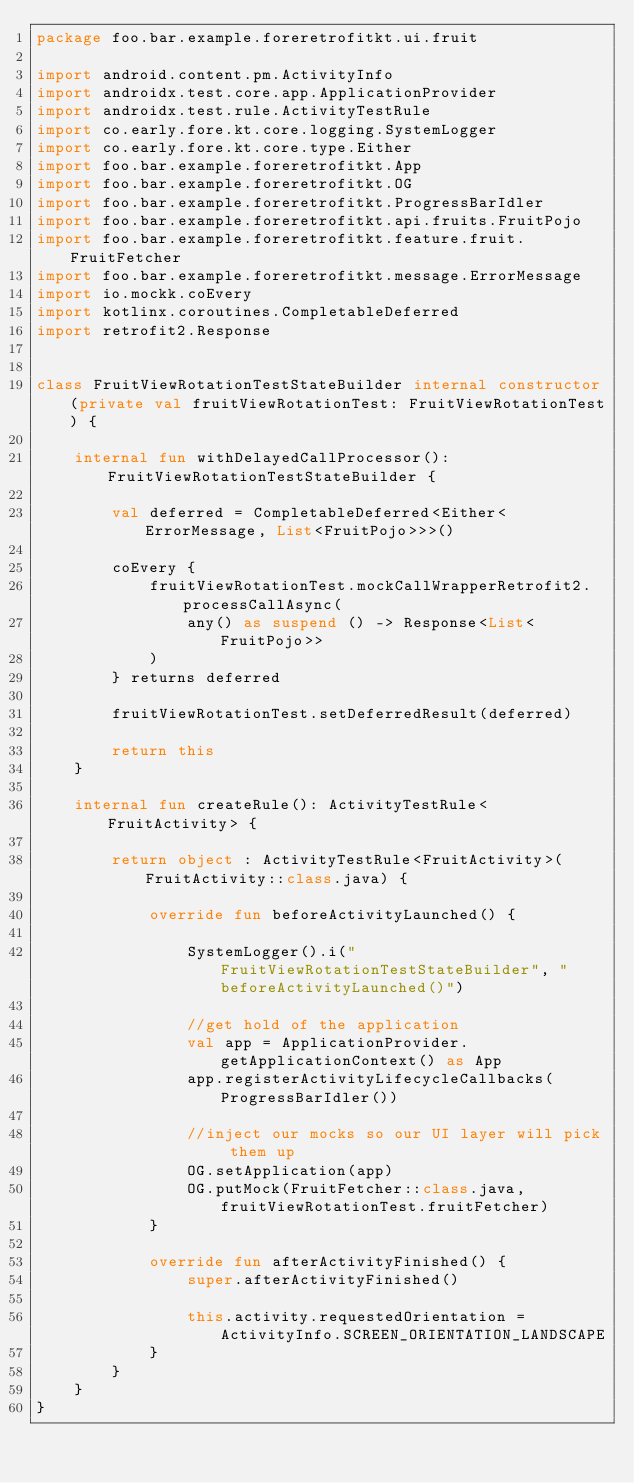Convert code to text. <code><loc_0><loc_0><loc_500><loc_500><_Kotlin_>package foo.bar.example.foreretrofitkt.ui.fruit

import android.content.pm.ActivityInfo
import androidx.test.core.app.ApplicationProvider
import androidx.test.rule.ActivityTestRule
import co.early.fore.kt.core.logging.SystemLogger
import co.early.fore.kt.core.type.Either
import foo.bar.example.foreretrofitkt.App
import foo.bar.example.foreretrofitkt.OG
import foo.bar.example.foreretrofitkt.ProgressBarIdler
import foo.bar.example.foreretrofitkt.api.fruits.FruitPojo
import foo.bar.example.foreretrofitkt.feature.fruit.FruitFetcher
import foo.bar.example.foreretrofitkt.message.ErrorMessage
import io.mockk.coEvery
import kotlinx.coroutines.CompletableDeferred
import retrofit2.Response


class FruitViewRotationTestStateBuilder internal constructor(private val fruitViewRotationTest: FruitViewRotationTest) {

    internal fun withDelayedCallProcessor(): FruitViewRotationTestStateBuilder {

        val deferred = CompletableDeferred<Either<ErrorMessage, List<FruitPojo>>>()

        coEvery {
            fruitViewRotationTest.mockCallWrapperRetrofit2.processCallAsync(
                any() as suspend () -> Response<List<FruitPojo>>
            )
        } returns deferred

        fruitViewRotationTest.setDeferredResult(deferred)

        return this
    }

    internal fun createRule(): ActivityTestRule<FruitActivity> {

        return object : ActivityTestRule<FruitActivity>(FruitActivity::class.java) {

            override fun beforeActivityLaunched() {

                SystemLogger().i("FruitViewRotationTestStateBuilder", "beforeActivityLaunched()")

                //get hold of the application
                val app = ApplicationProvider.getApplicationContext() as App
                app.registerActivityLifecycleCallbacks(ProgressBarIdler())

                //inject our mocks so our UI layer will pick them up
                OG.setApplication(app)
                OG.putMock(FruitFetcher::class.java, fruitViewRotationTest.fruitFetcher)
            }

            override fun afterActivityFinished() {
                super.afterActivityFinished()

                this.activity.requestedOrientation = ActivityInfo.SCREEN_ORIENTATION_LANDSCAPE
            }
        }
    }
}
</code> 